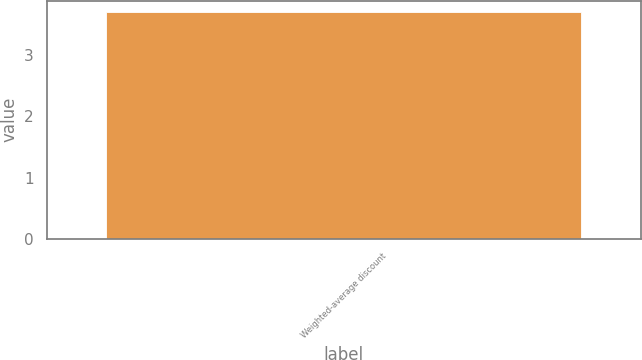<chart> <loc_0><loc_0><loc_500><loc_500><bar_chart><fcel>Weighted-average discount<nl><fcel>3.7<nl></chart> 